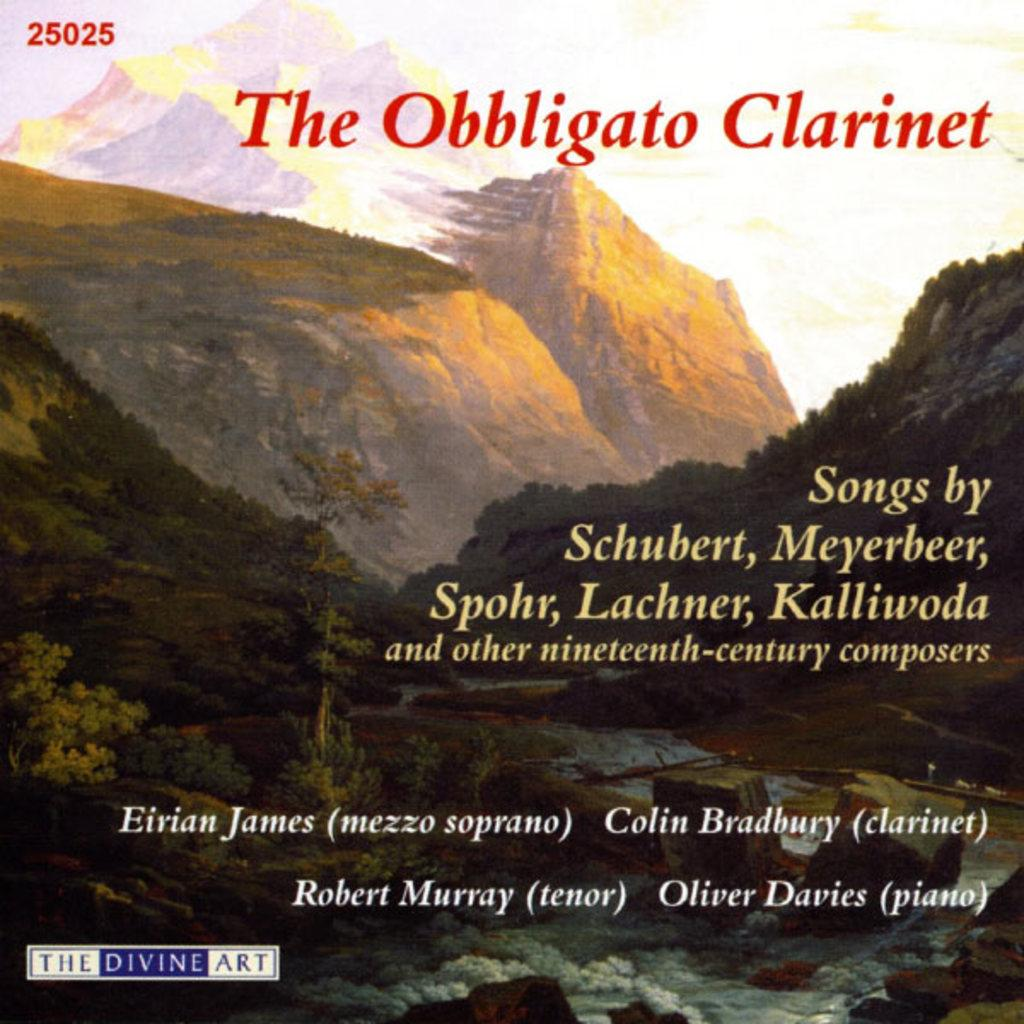<image>
Give a short and clear explanation of the subsequent image. a book that has the numbers 25025 on it 